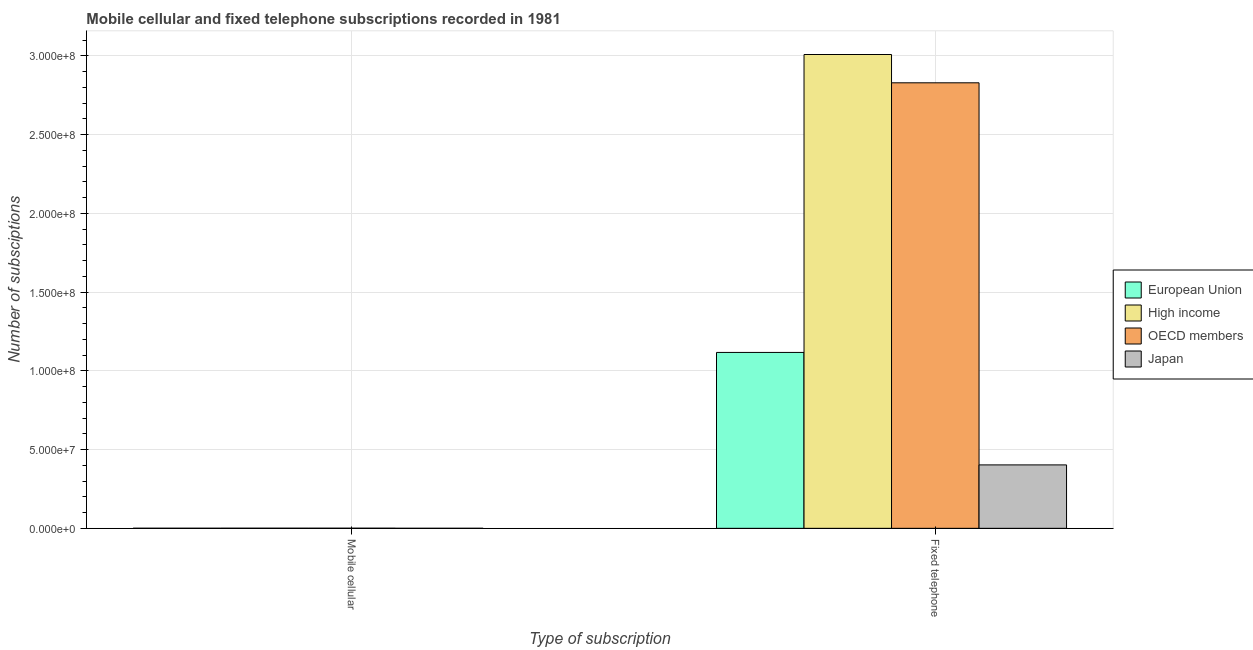How many different coloured bars are there?
Offer a very short reply. 4. Are the number of bars per tick equal to the number of legend labels?
Keep it short and to the point. Yes. Are the number of bars on each tick of the X-axis equal?
Offer a very short reply. Yes. How many bars are there on the 2nd tick from the left?
Your answer should be compact. 4. What is the label of the 1st group of bars from the left?
Your answer should be compact. Mobile cellular. What is the number of fixed telephone subscriptions in European Union?
Offer a terse response. 1.12e+08. Across all countries, what is the maximum number of fixed telephone subscriptions?
Make the answer very short. 3.01e+08. Across all countries, what is the minimum number of mobile cellular subscriptions?
Provide a short and direct response. 1.33e+04. What is the total number of mobile cellular subscriptions in the graph?
Offer a terse response. 1.89e+05. What is the difference between the number of mobile cellular subscriptions in OECD members and that in Japan?
Make the answer very short. 5.03e+04. What is the difference between the number of fixed telephone subscriptions in OECD members and the number of mobile cellular subscriptions in High income?
Offer a terse response. 2.83e+08. What is the average number of mobile cellular subscriptions per country?
Ensure brevity in your answer.  4.73e+04. What is the difference between the number of mobile cellular subscriptions and number of fixed telephone subscriptions in European Union?
Give a very brief answer. -1.12e+08. What is the ratio of the number of fixed telephone subscriptions in High income to that in Japan?
Provide a succinct answer. 7.47. How many bars are there?
Provide a short and direct response. 8. Are all the bars in the graph horizontal?
Your answer should be very brief. No. What is the difference between two consecutive major ticks on the Y-axis?
Provide a succinct answer. 5.00e+07. Does the graph contain any zero values?
Your answer should be very brief. No. Where does the legend appear in the graph?
Your answer should be very brief. Center right. How many legend labels are there?
Your answer should be compact. 4. What is the title of the graph?
Ensure brevity in your answer.  Mobile cellular and fixed telephone subscriptions recorded in 1981. Does "Pacific island small states" appear as one of the legend labels in the graph?
Provide a succinct answer. No. What is the label or title of the X-axis?
Offer a very short reply. Type of subscription. What is the label or title of the Y-axis?
Make the answer very short. Number of subsciptions. What is the Number of subsciptions of European Union in Mobile cellular?
Your response must be concise. 4.86e+04. What is the Number of subsciptions of High income in Mobile cellular?
Your answer should be very brief. 6.36e+04. What is the Number of subsciptions of OECD members in Mobile cellular?
Your answer should be very brief. 6.36e+04. What is the Number of subsciptions of Japan in Mobile cellular?
Provide a succinct answer. 1.33e+04. What is the Number of subsciptions in European Union in Fixed telephone?
Your response must be concise. 1.12e+08. What is the Number of subsciptions of High income in Fixed telephone?
Keep it short and to the point. 3.01e+08. What is the Number of subsciptions in OECD members in Fixed telephone?
Provide a short and direct response. 2.83e+08. What is the Number of subsciptions in Japan in Fixed telephone?
Make the answer very short. 4.03e+07. Across all Type of subscription, what is the maximum Number of subsciptions of European Union?
Make the answer very short. 1.12e+08. Across all Type of subscription, what is the maximum Number of subsciptions in High income?
Your answer should be very brief. 3.01e+08. Across all Type of subscription, what is the maximum Number of subsciptions in OECD members?
Make the answer very short. 2.83e+08. Across all Type of subscription, what is the maximum Number of subsciptions in Japan?
Keep it short and to the point. 4.03e+07. Across all Type of subscription, what is the minimum Number of subsciptions of European Union?
Ensure brevity in your answer.  4.86e+04. Across all Type of subscription, what is the minimum Number of subsciptions of High income?
Offer a terse response. 6.36e+04. Across all Type of subscription, what is the minimum Number of subsciptions of OECD members?
Provide a short and direct response. 6.36e+04. Across all Type of subscription, what is the minimum Number of subsciptions of Japan?
Your answer should be compact. 1.33e+04. What is the total Number of subsciptions of European Union in the graph?
Provide a succinct answer. 1.12e+08. What is the total Number of subsciptions of High income in the graph?
Your answer should be compact. 3.01e+08. What is the total Number of subsciptions of OECD members in the graph?
Offer a very short reply. 2.83e+08. What is the total Number of subsciptions of Japan in the graph?
Your answer should be compact. 4.03e+07. What is the difference between the Number of subsciptions of European Union in Mobile cellular and that in Fixed telephone?
Your response must be concise. -1.12e+08. What is the difference between the Number of subsciptions of High income in Mobile cellular and that in Fixed telephone?
Your answer should be very brief. -3.01e+08. What is the difference between the Number of subsciptions of OECD members in Mobile cellular and that in Fixed telephone?
Provide a short and direct response. -2.83e+08. What is the difference between the Number of subsciptions in Japan in Mobile cellular and that in Fixed telephone?
Your response must be concise. -4.03e+07. What is the difference between the Number of subsciptions in European Union in Mobile cellular and the Number of subsciptions in High income in Fixed telephone?
Provide a succinct answer. -3.01e+08. What is the difference between the Number of subsciptions in European Union in Mobile cellular and the Number of subsciptions in OECD members in Fixed telephone?
Your response must be concise. -2.83e+08. What is the difference between the Number of subsciptions of European Union in Mobile cellular and the Number of subsciptions of Japan in Fixed telephone?
Make the answer very short. -4.02e+07. What is the difference between the Number of subsciptions in High income in Mobile cellular and the Number of subsciptions in OECD members in Fixed telephone?
Your answer should be very brief. -2.83e+08. What is the difference between the Number of subsciptions in High income in Mobile cellular and the Number of subsciptions in Japan in Fixed telephone?
Give a very brief answer. -4.02e+07. What is the difference between the Number of subsciptions in OECD members in Mobile cellular and the Number of subsciptions in Japan in Fixed telephone?
Provide a short and direct response. -4.02e+07. What is the average Number of subsciptions in European Union per Type of subscription?
Make the answer very short. 5.59e+07. What is the average Number of subsciptions of High income per Type of subscription?
Provide a succinct answer. 1.50e+08. What is the average Number of subsciptions in OECD members per Type of subscription?
Offer a terse response. 1.42e+08. What is the average Number of subsciptions of Japan per Type of subscription?
Give a very brief answer. 2.01e+07. What is the difference between the Number of subsciptions in European Union and Number of subsciptions in High income in Mobile cellular?
Give a very brief answer. -1.49e+04. What is the difference between the Number of subsciptions in European Union and Number of subsciptions in OECD members in Mobile cellular?
Provide a short and direct response. -1.49e+04. What is the difference between the Number of subsciptions of European Union and Number of subsciptions of Japan in Mobile cellular?
Offer a very short reply. 3.54e+04. What is the difference between the Number of subsciptions in High income and Number of subsciptions in OECD members in Mobile cellular?
Offer a terse response. 0. What is the difference between the Number of subsciptions of High income and Number of subsciptions of Japan in Mobile cellular?
Keep it short and to the point. 5.03e+04. What is the difference between the Number of subsciptions in OECD members and Number of subsciptions in Japan in Mobile cellular?
Offer a very short reply. 5.03e+04. What is the difference between the Number of subsciptions of European Union and Number of subsciptions of High income in Fixed telephone?
Offer a very short reply. -1.89e+08. What is the difference between the Number of subsciptions in European Union and Number of subsciptions in OECD members in Fixed telephone?
Provide a succinct answer. -1.71e+08. What is the difference between the Number of subsciptions in European Union and Number of subsciptions in Japan in Fixed telephone?
Offer a terse response. 7.14e+07. What is the difference between the Number of subsciptions of High income and Number of subsciptions of OECD members in Fixed telephone?
Your answer should be very brief. 1.80e+07. What is the difference between the Number of subsciptions of High income and Number of subsciptions of Japan in Fixed telephone?
Provide a short and direct response. 2.61e+08. What is the difference between the Number of subsciptions of OECD members and Number of subsciptions of Japan in Fixed telephone?
Make the answer very short. 2.43e+08. What is the ratio of the Number of subsciptions in European Union in Mobile cellular to that in Fixed telephone?
Keep it short and to the point. 0. What is the ratio of the Number of subsciptions in High income in Mobile cellular to that in Fixed telephone?
Offer a terse response. 0. What is the difference between the highest and the second highest Number of subsciptions in European Union?
Ensure brevity in your answer.  1.12e+08. What is the difference between the highest and the second highest Number of subsciptions of High income?
Make the answer very short. 3.01e+08. What is the difference between the highest and the second highest Number of subsciptions of OECD members?
Provide a succinct answer. 2.83e+08. What is the difference between the highest and the second highest Number of subsciptions of Japan?
Offer a very short reply. 4.03e+07. What is the difference between the highest and the lowest Number of subsciptions in European Union?
Make the answer very short. 1.12e+08. What is the difference between the highest and the lowest Number of subsciptions in High income?
Make the answer very short. 3.01e+08. What is the difference between the highest and the lowest Number of subsciptions of OECD members?
Provide a short and direct response. 2.83e+08. What is the difference between the highest and the lowest Number of subsciptions in Japan?
Provide a succinct answer. 4.03e+07. 